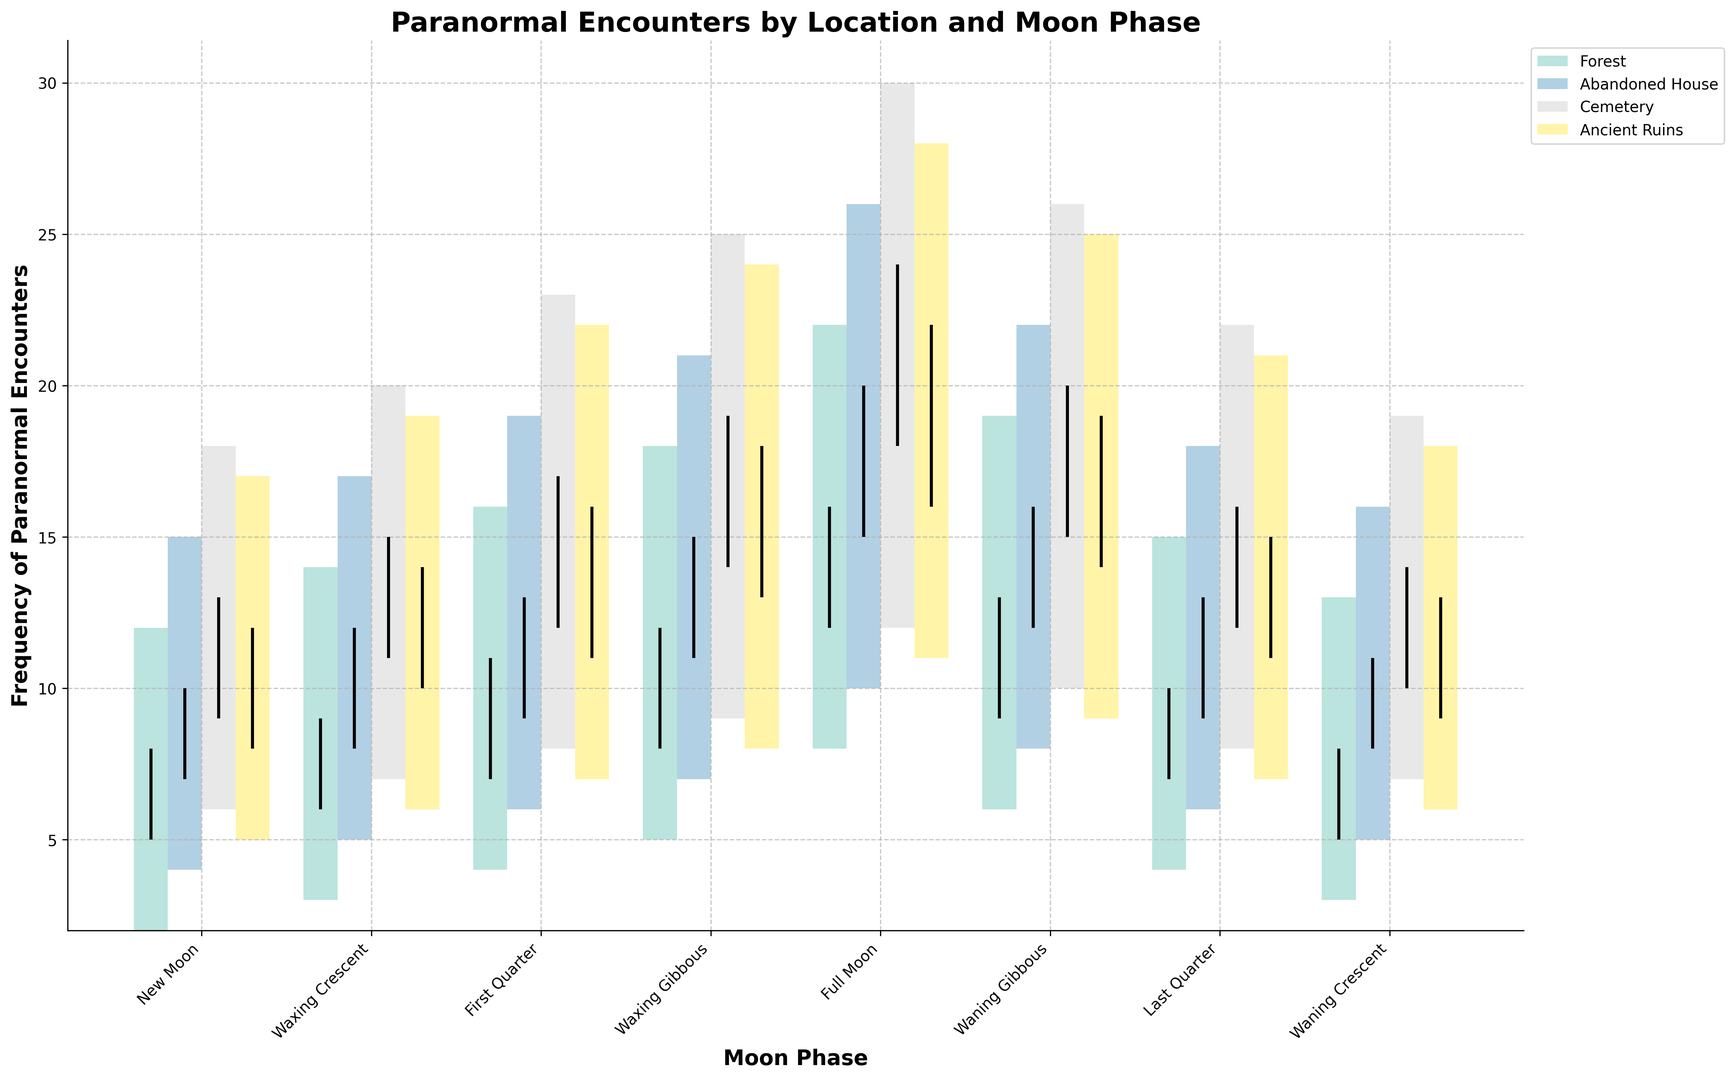What moon phase has the highest frequency of paranormal encounters in Ancient Ruins? The highest frequency of paranormal encounters in Ancient Ruins occurs during the Full Moon, where the 'High' value reaches 28.
Answer: Full Moon Between Forest and Abandoned House, which location has a higher frequency of paranormal encounters during the Waning Crescent moon phase? The high value for Forest during the Waning Crescent is 13, while for Abandoned House it is 16. Therefore, Abandoned House has a higher frequency.
Answer: Abandoned House What is the average high value of paranormal encounters reported in the Cemetery across all moon phases? Sum all high values for the Cemetery (18 + 20 + 23 + 25 + 30 + 26 + 22 + 19 = 183) and divide by the number of moon phases (8). So, the average high value is 183/8 = 22.875.
Answer: 22.875 During which moon phase is the difference between the high and low frequency of paranormal encounters the smallest in the Forest? By calculating the difference (High - Low) for each moon phase in the Forest: New Moon (10), Waxing Crescent (11), First Quarter (12), Waxing Gibbous (13), Full Moon (14), Waning Gibbous (13), Last Quarter (11), Waning Crescent (10); the smallest difference is during the New and Waning Crescent phases where the difference is 10.
Answer: New Moon and Waning Crescent Which location reports the highest number of paranormal encounters during the Full Moon phase? Among all locations, the Full Moon high values are: Forest (22), Abandoned House (26), Cemetery (30), and Ancient Ruins (28). The Cemetery has the highest number with 30 encounters.
Answer: Cemetery Between the New Moon and the First Quarter, which moon phase shows a higher average number of open encounters in the Abandoned House? For Abandoned House, New Moon (Open = 7), First Quarter (Open = 9). The average of these values is (7 + 9) / 2 = 8.
Answer: First Quarter Does the frequency of paranormal encounters ever decrease during the transition from Waxing Crescent to First Quarter in any location? By comparing the 'High' values from Waxing Crescent to First Quarter: Forest (14 to 16), Abandoned House (17 to 19), Cemetery (20 to 23), Ancient Ruins (19 to 22). In all locations, the frequency increases.
Answer: No What's the difference in the maximum reported encounters between the Full Moon and Waning Crescent phase in Ancient Ruins? In Ancient Ruins, the high value during the Full Moon is 28 and during the Waning Crescent it is 18. The difference between them is 28 - 18 = 10.
Answer: 10 